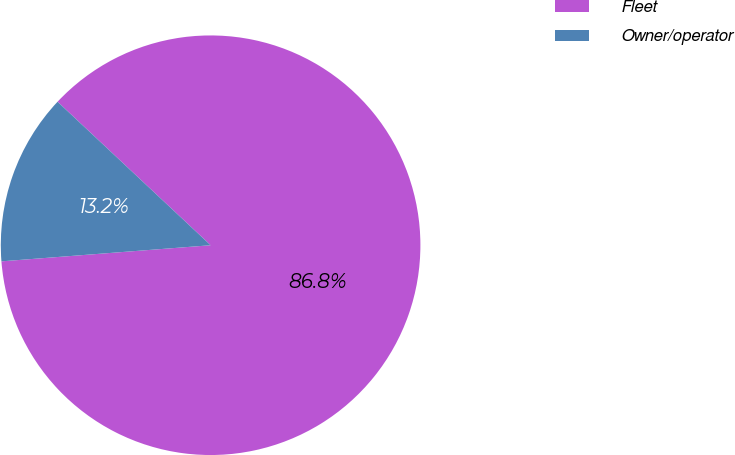<chart> <loc_0><loc_0><loc_500><loc_500><pie_chart><fcel>Fleet<fcel>Owner/operator<nl><fcel>86.79%<fcel>13.21%<nl></chart> 